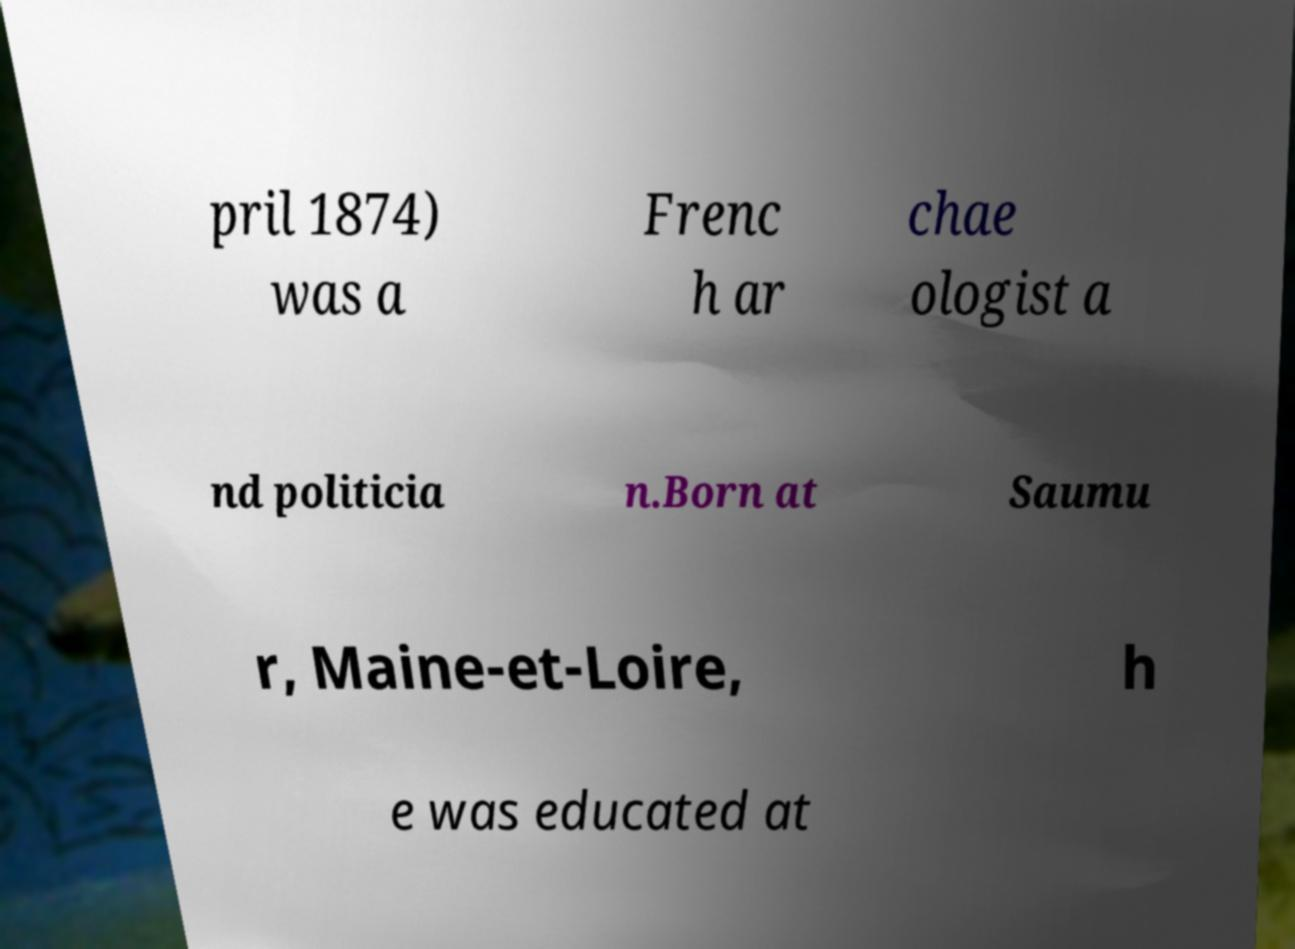Please read and relay the text visible in this image. What does it say? pril 1874) was a Frenc h ar chae ologist a nd politicia n.Born at Saumu r, Maine-et-Loire, h e was educated at 